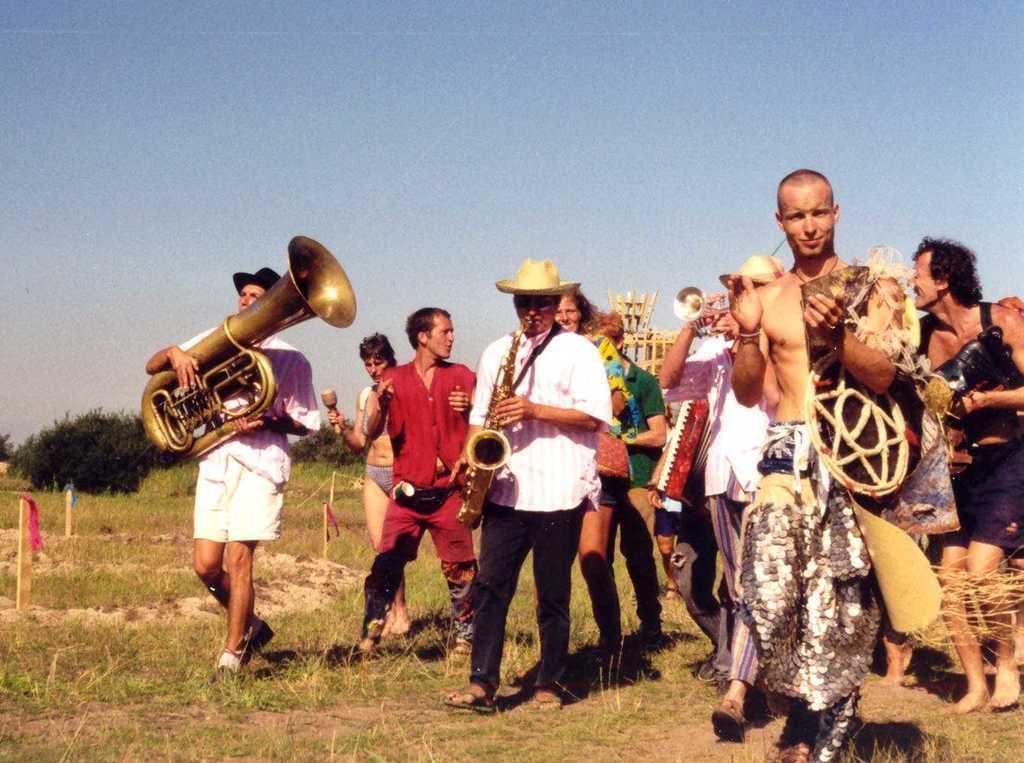Could you give a brief overview of what you see in this image? In this image there are a few people walking on the ground. They are holding musical instruments in their hands. The man in the center is playing a trumpet. There are is grass on the ground. To the left there are rods on the ground. Behind them there are plants. At the top there is the sky. 